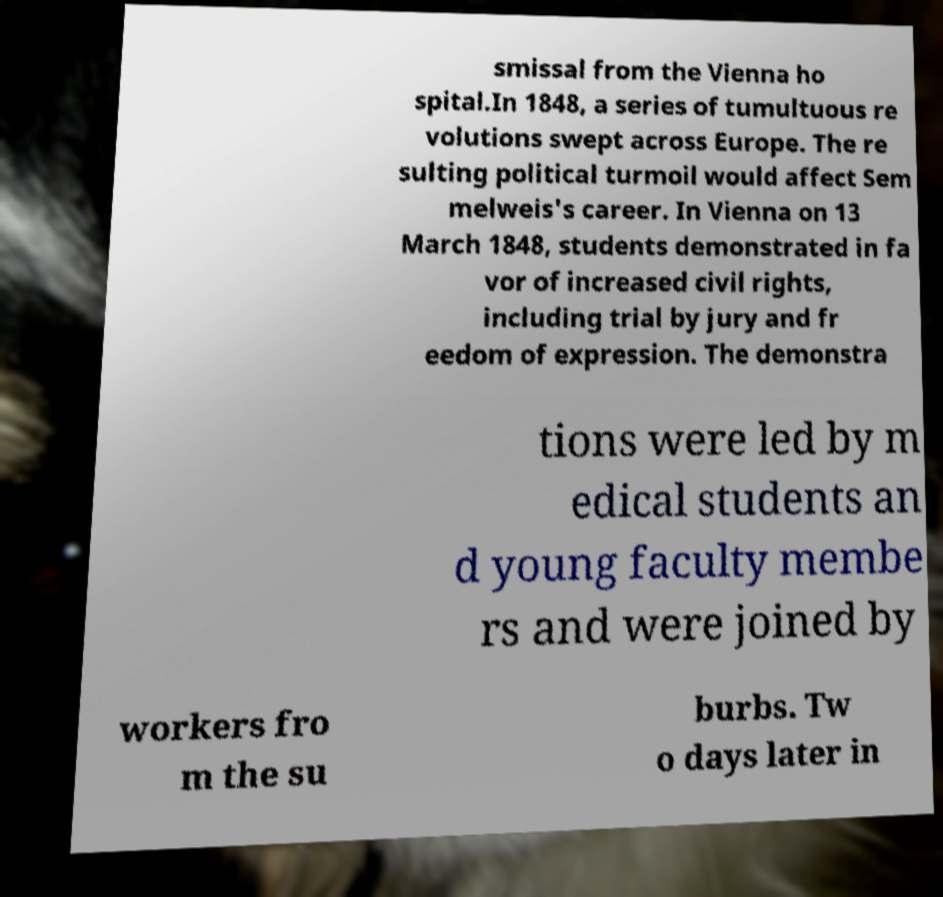What messages or text are displayed in this image? I need them in a readable, typed format. smissal from the Vienna ho spital.In 1848, a series of tumultuous re volutions swept across Europe. The re sulting political turmoil would affect Sem melweis's career. In Vienna on 13 March 1848, students demonstrated in fa vor of increased civil rights, including trial by jury and fr eedom of expression. The demonstra tions were led by m edical students an d young faculty membe rs and were joined by workers fro m the su burbs. Tw o days later in 